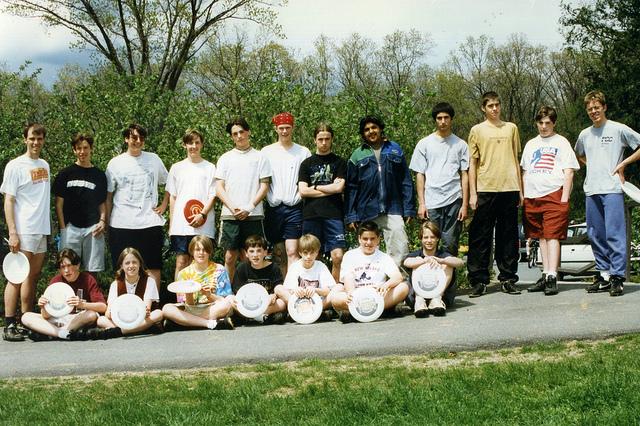How many people are sitting down?
Quick response, please. 7. What agency does this picture represent?
Short answer required. Frisbee team. How many kids are in the first row?
Keep it brief. 7. Are they all wearing white?
Concise answer only. No. Why aren't two of the individuals in the picture wearing jerseys?
Write a very short answer. Not on team. What type of team is this?
Quick response, please. Frisbee. What sport do they play?
Give a very brief answer. Frisbee. What is the baseball teams name?
Answer briefly. Padres. Is the crowd dressed nicely?
Short answer required. No. What are they holding in their hands?
Write a very short answer. Frisbees. 